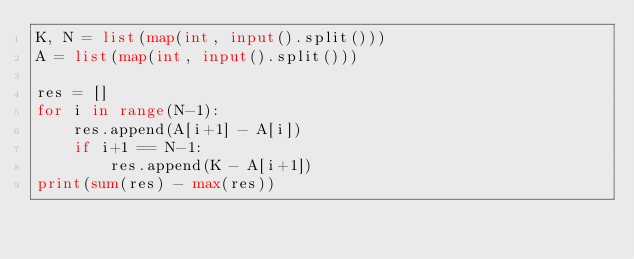Convert code to text. <code><loc_0><loc_0><loc_500><loc_500><_Python_>K, N = list(map(int, input().split()))
A = list(map(int, input().split()))

res = []
for i in range(N-1):
    res.append(A[i+1] - A[i])
    if i+1 == N-1:
        res.append(K - A[i+1])
print(sum(res) - max(res))</code> 